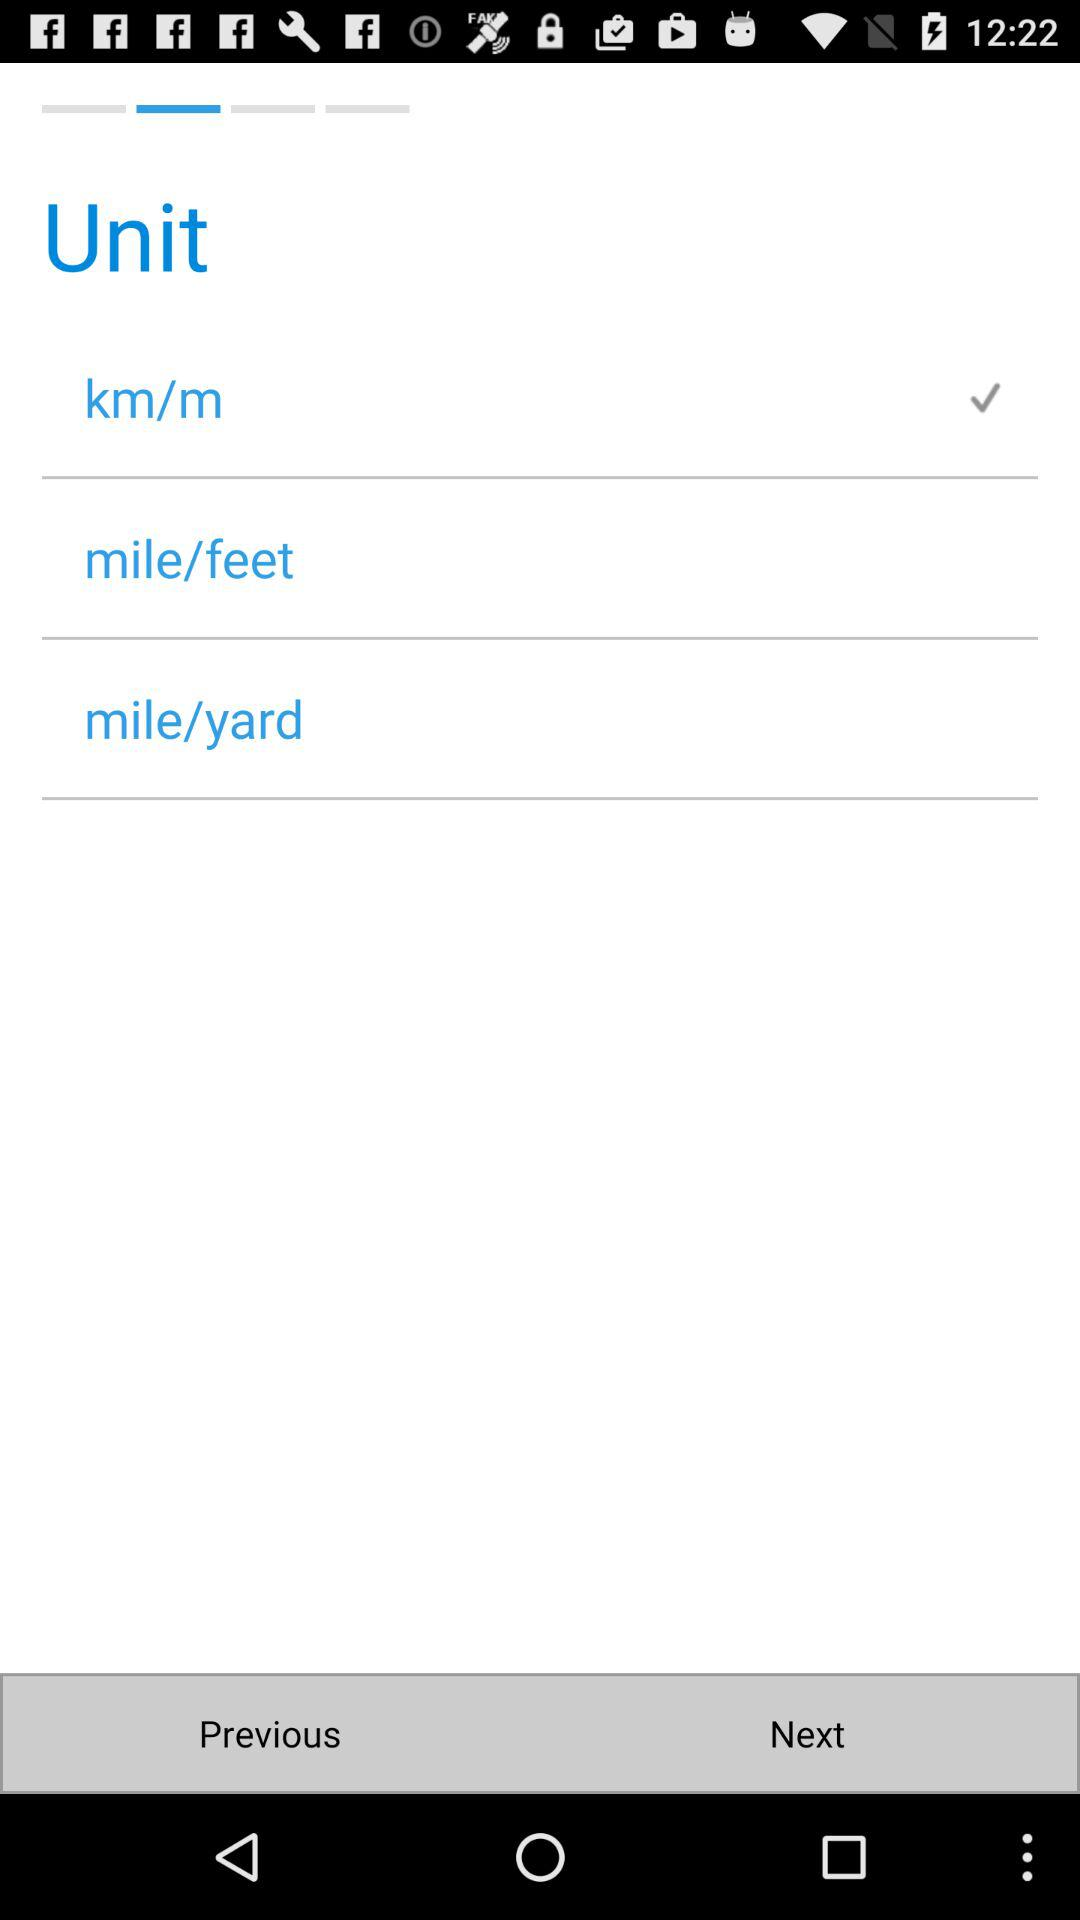How many units are not checked?
Answer the question using a single word or phrase. 2 